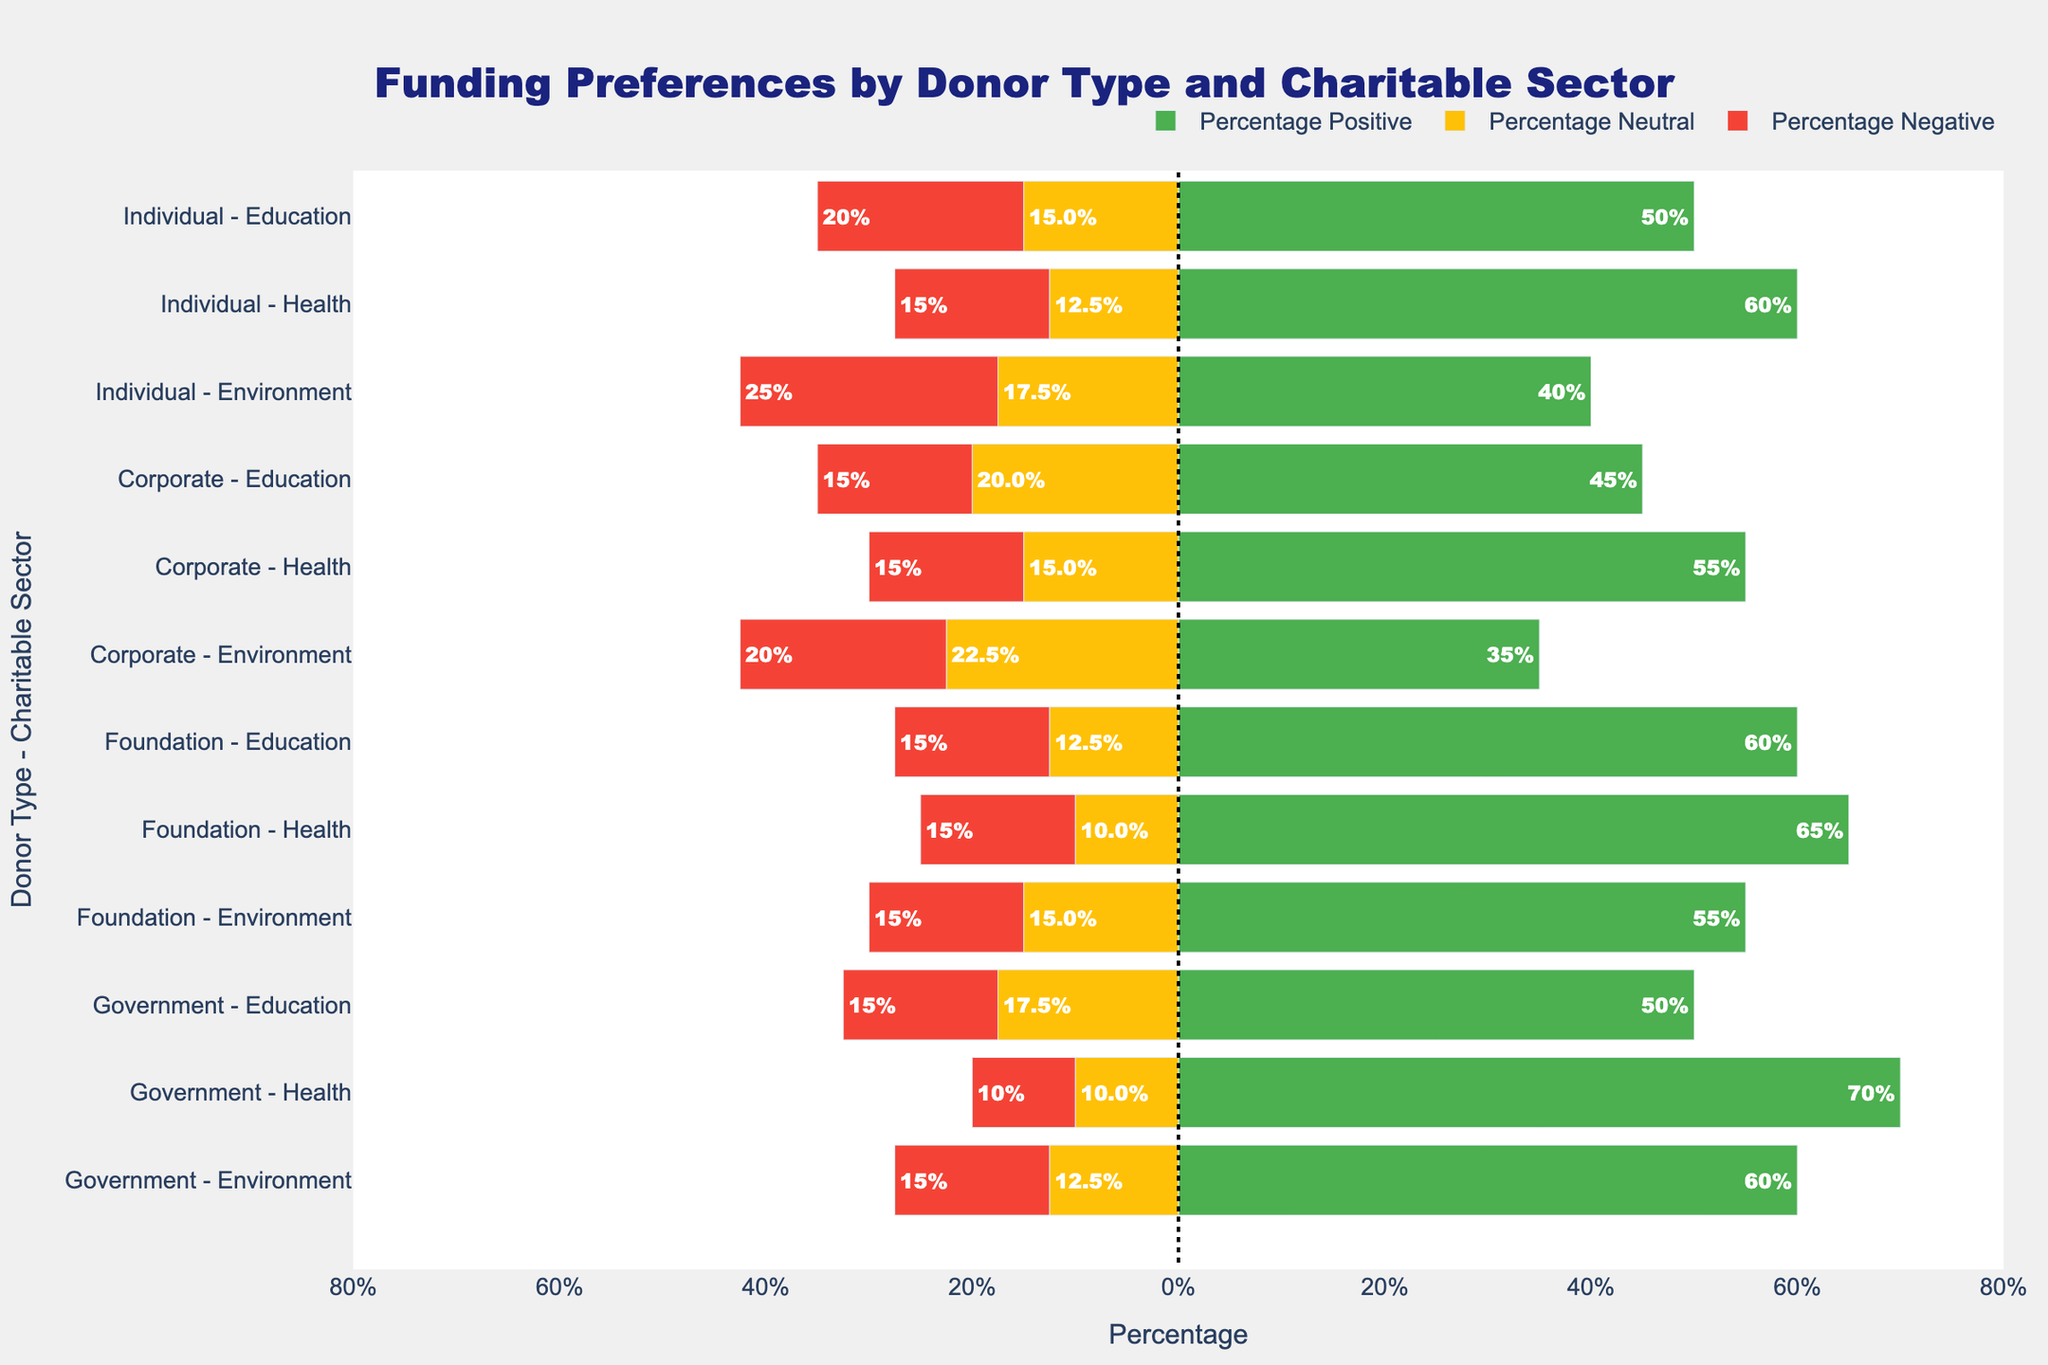Which donor type shows the highest percentage positive sentiment for the Health sector? By looking at the Health sector bars for each donor type, the highest percentage positive sentiment is shown by the Government, with 70%.
Answer: Government In the Education sector, what is the difference in percentage positive sentiment between Foundation and Corporate donors? For the Education sector, Foundation has 60% positive sentiment, and Corporate has 45%. The difference is 60% - 45% = 15%.
Answer: 15% Which donor type and sector combination shows the highest percentage neutral sentiment? By observing the longest yellow bars (indicating neutral sentiment) in the chart, Corporate donors for the Environment sector show the highest percentage neutral sentiment at 45%.
Answer: Corporate - Environment What is the combined negative and neutral sentiment percentage for Individual donors in the Environment sector? For Individual donors in the Environment sector, the neutral sentiment is 35% and the negative sentiment is 25%. The combined percentage is 35% + 25% = 60%.
Answer: 60% Compare the positive sentiment of Corporate donors for the Health and Environment sectors. Which is higher and by how much? For Corporate donors, the Health sector has 55% positive sentiment, and the Environment sector has 35%. The difference is 55% - 35% = 20%.
Answer: Health by 20% Which charitable sector receives the lowest positive sentiment from any donor type? By examining the shortest green bars representing positive sentiment across sectors, the lowest positive sentiment is 35% for the Environment sector by Corporate donors.
Answer: Environment What is the average percentage positive sentiment for Government donors across all sectors? Add the positive sentiments for Government donors across all sectors: Education (50%), Health (70%), and Environment (60%). Then divide by 3: (50% + 70% + 60%) / 3 = 60%.
Answer: 60% Of the Individual donors, which sector shows the highest percentage of negative sentiment? For Individual donors, the highest percentage of negative sentiment is 25% in the Environment sector.
Answer: Environment What is the range (difference between highest and lowest) of percentage positive sentiment for Foundation donors across all charitable sectors? For Foundation donors, the highest positive sentiment is 65% (Health), and the lowest is 55% (Environment). The range is 65% - 55% = 10%.
Answer: 10% 